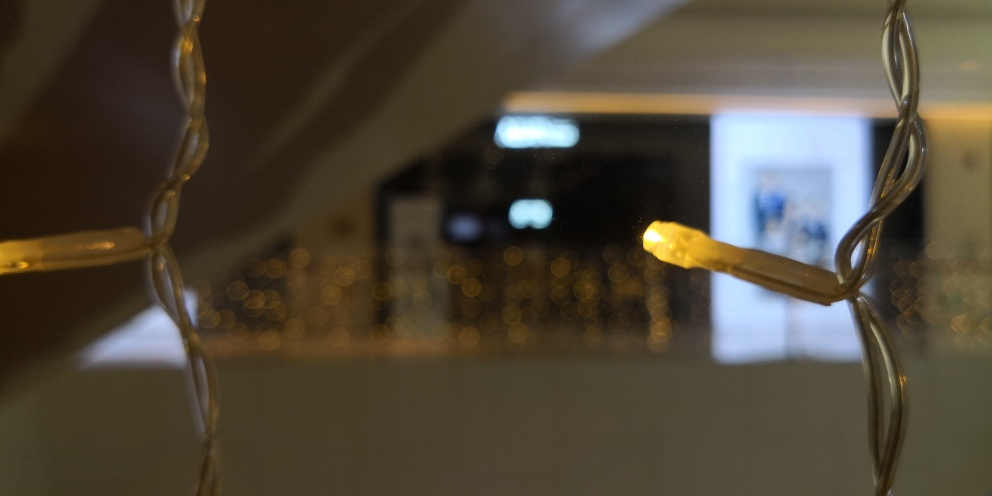What mood does the lighting in the image evoke? The lighting in the image creates an intimate and warm atmosphere, often associated with cozy, festive, or contemplative moments. The soft glow from the lights provides a sense of tranquility and comfort. 